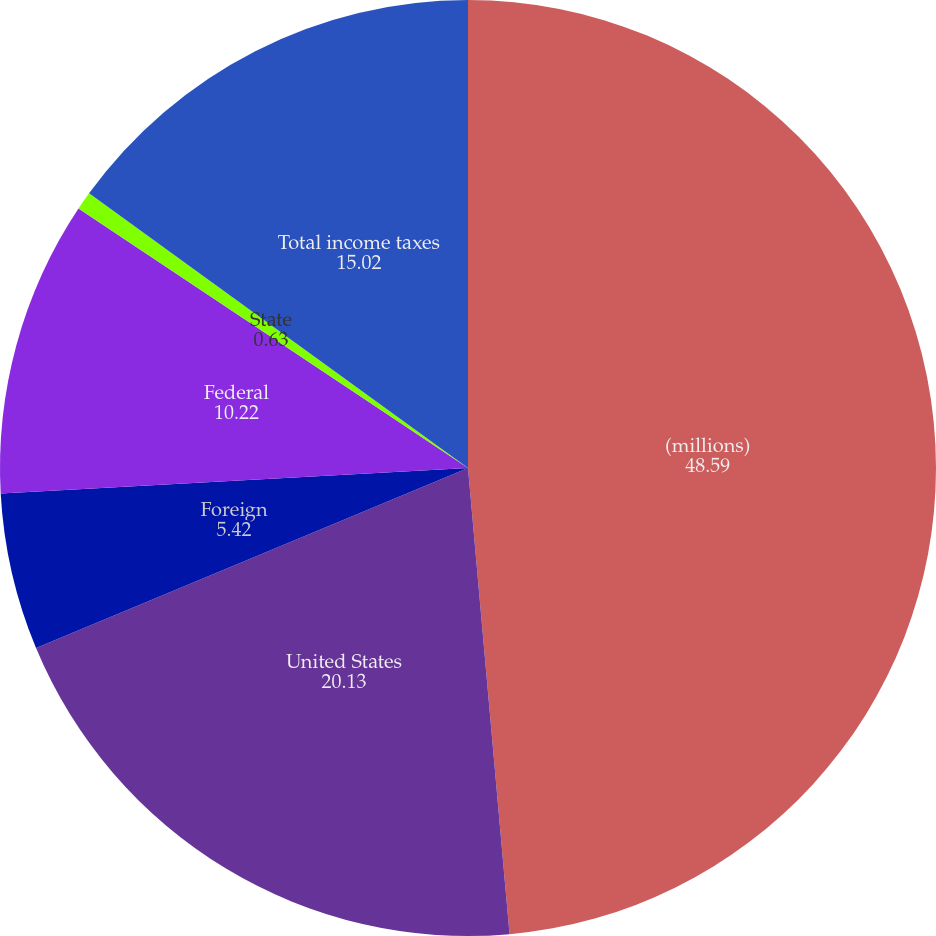<chart> <loc_0><loc_0><loc_500><loc_500><pie_chart><fcel>(millions)<fcel>United States<fcel>Foreign<fcel>Federal<fcel>State<fcel>Total income taxes<nl><fcel>48.59%<fcel>20.13%<fcel>5.42%<fcel>10.22%<fcel>0.63%<fcel>15.02%<nl></chart> 